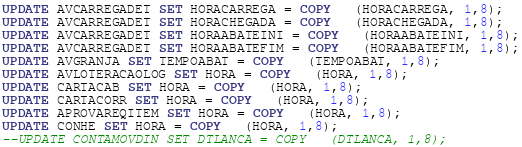Convert code to text. <code><loc_0><loc_0><loc_500><loc_500><_SQL_>UPDATE AVCARREGADET SET HORACARREGA = COPY   (HORACARREGA, 1,8);
UPDATE AVCARREGADET SET HORACHEGADA = COPY   (HORACHEGADA, 1,8);
UPDATE AVCARREGADET SET HORAABATEINI = COPY   (HORAABATEINI, 1,8);
UPDATE AVCARREGADET SET HORAABATEFIM = COPY   (HORAABATEFIM, 1,8);
UPDATE AVGRANJA SET TEMPOABAT = COPY   (TEMPOABAT, 1,8);
UPDATE AVLOTERACAOLOG SET HORA = COPY   (HORA, 1,8);
UPDATE CARTACAB SET HORA = COPY   (HORA, 1,8);
UPDATE CARTACORR SET HORA = COPY   (HORA, 1,8);
UPDATE APROVAREQITEM SET HORA = COPY   (HORA, 1,8);
UPDATE CONHE SET HORA = COPY   (HORA, 1,8);
--UPDATE CONTAMOVDIN SET DTLANCA = COPY   (DTLANCA, 1,8);</code> 